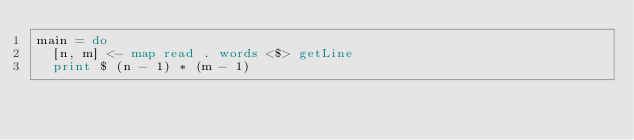Convert code to text. <code><loc_0><loc_0><loc_500><loc_500><_Haskell_>main = do
  [n, m] <- map read . words <$> getLine
  print $ (n - 1) * (m - 1)</code> 